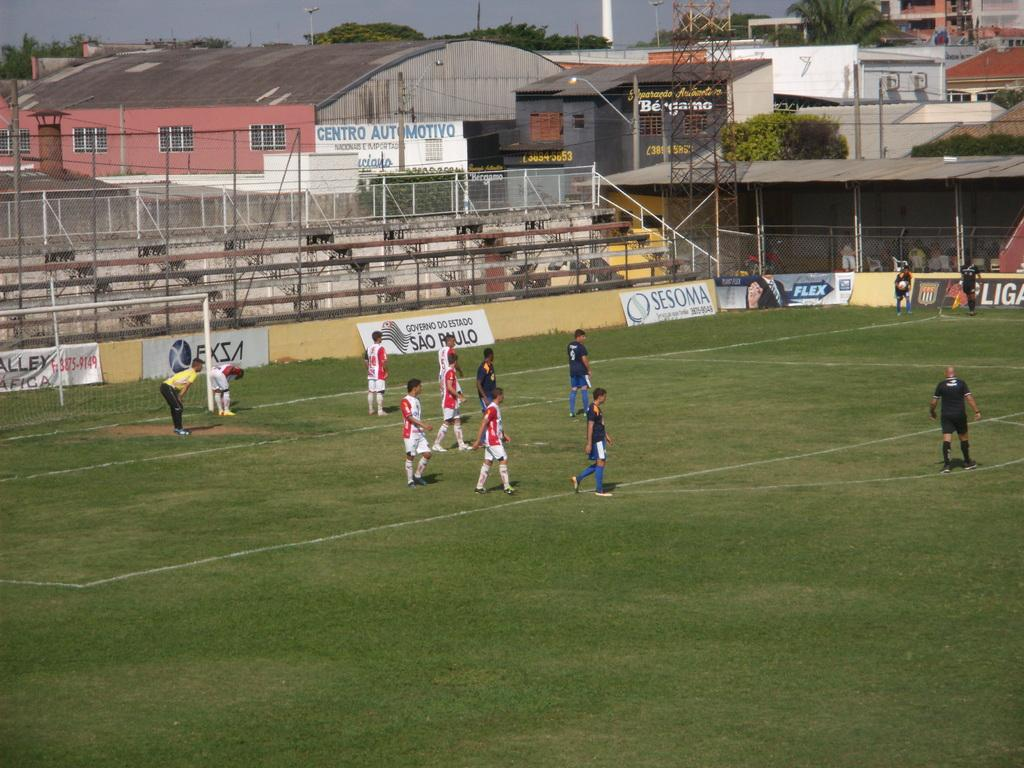<image>
Offer a succinct explanation of the picture presented. A soccer field has a banner in white with blue letters of Sesoma. 